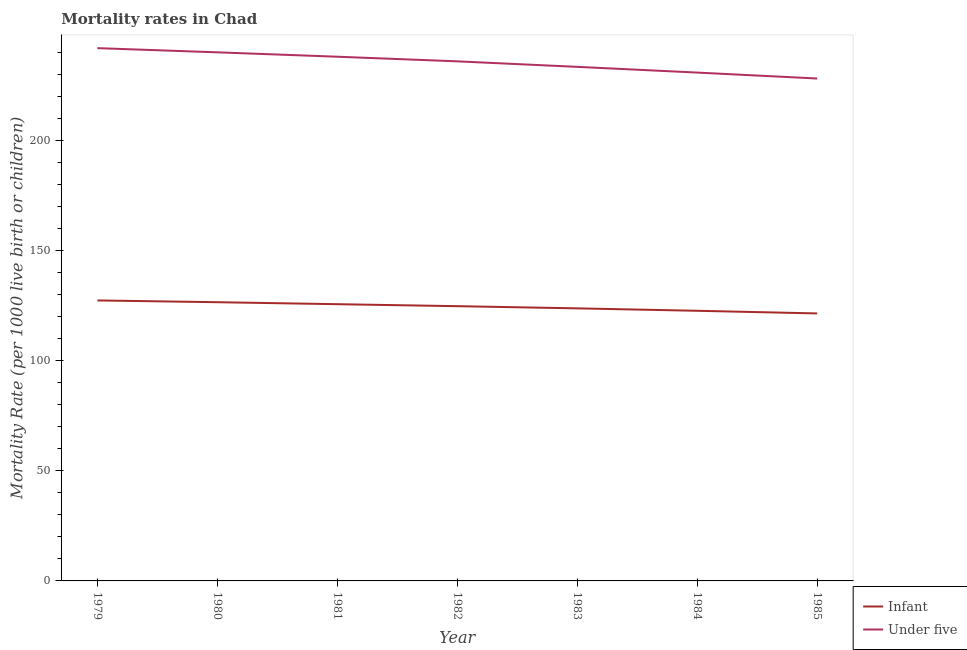How many different coloured lines are there?
Offer a very short reply. 2. Is the number of lines equal to the number of legend labels?
Keep it short and to the point. Yes. What is the under-5 mortality rate in 1984?
Offer a very short reply. 230.9. Across all years, what is the maximum infant mortality rate?
Give a very brief answer. 127.4. Across all years, what is the minimum under-5 mortality rate?
Provide a succinct answer. 228.2. In which year was the under-5 mortality rate maximum?
Ensure brevity in your answer.  1979. What is the total infant mortality rate in the graph?
Offer a terse response. 872.5. What is the difference between the infant mortality rate in 1979 and that in 1981?
Offer a terse response. 1.7. What is the difference between the under-5 mortality rate in 1985 and the infant mortality rate in 1980?
Keep it short and to the point. 101.6. What is the average infant mortality rate per year?
Give a very brief answer. 124.64. In the year 1979, what is the difference between the infant mortality rate and under-5 mortality rate?
Provide a succinct answer. -114.6. In how many years, is the infant mortality rate greater than 60?
Your answer should be very brief. 7. What is the ratio of the infant mortality rate in 1979 to that in 1984?
Your answer should be compact. 1.04. Is the infant mortality rate in 1984 less than that in 1985?
Your answer should be compact. No. Is the difference between the infant mortality rate in 1979 and 1982 greater than the difference between the under-5 mortality rate in 1979 and 1982?
Provide a short and direct response. No. What is the difference between the highest and the second highest under-5 mortality rate?
Ensure brevity in your answer.  1.9. What is the difference between the highest and the lowest under-5 mortality rate?
Offer a terse response. 13.8. In how many years, is the under-5 mortality rate greater than the average under-5 mortality rate taken over all years?
Keep it short and to the point. 4. Is the sum of the infant mortality rate in 1980 and 1984 greater than the maximum under-5 mortality rate across all years?
Give a very brief answer. Yes. Does the infant mortality rate monotonically increase over the years?
Offer a terse response. No. How many lines are there?
Keep it short and to the point. 2. Does the graph contain any zero values?
Your answer should be compact. No. Does the graph contain grids?
Provide a succinct answer. No. How many legend labels are there?
Keep it short and to the point. 2. What is the title of the graph?
Provide a succinct answer. Mortality rates in Chad. What is the label or title of the Y-axis?
Your answer should be very brief. Mortality Rate (per 1000 live birth or children). What is the Mortality Rate (per 1000 live birth or children) in Infant in 1979?
Give a very brief answer. 127.4. What is the Mortality Rate (per 1000 live birth or children) in Under five in 1979?
Provide a short and direct response. 242. What is the Mortality Rate (per 1000 live birth or children) of Infant in 1980?
Your answer should be compact. 126.6. What is the Mortality Rate (per 1000 live birth or children) of Under five in 1980?
Provide a short and direct response. 240.1. What is the Mortality Rate (per 1000 live birth or children) in Infant in 1981?
Offer a terse response. 125.7. What is the Mortality Rate (per 1000 live birth or children) of Under five in 1981?
Your answer should be compact. 238.1. What is the Mortality Rate (per 1000 live birth or children) of Infant in 1982?
Ensure brevity in your answer.  124.8. What is the Mortality Rate (per 1000 live birth or children) of Under five in 1982?
Provide a short and direct response. 236. What is the Mortality Rate (per 1000 live birth or children) of Infant in 1983?
Offer a terse response. 123.8. What is the Mortality Rate (per 1000 live birth or children) of Under five in 1983?
Provide a short and direct response. 233.5. What is the Mortality Rate (per 1000 live birth or children) in Infant in 1984?
Offer a very short reply. 122.7. What is the Mortality Rate (per 1000 live birth or children) of Under five in 1984?
Offer a terse response. 230.9. What is the Mortality Rate (per 1000 live birth or children) in Infant in 1985?
Give a very brief answer. 121.5. What is the Mortality Rate (per 1000 live birth or children) in Under five in 1985?
Ensure brevity in your answer.  228.2. Across all years, what is the maximum Mortality Rate (per 1000 live birth or children) of Infant?
Make the answer very short. 127.4. Across all years, what is the maximum Mortality Rate (per 1000 live birth or children) in Under five?
Make the answer very short. 242. Across all years, what is the minimum Mortality Rate (per 1000 live birth or children) in Infant?
Make the answer very short. 121.5. Across all years, what is the minimum Mortality Rate (per 1000 live birth or children) in Under five?
Offer a terse response. 228.2. What is the total Mortality Rate (per 1000 live birth or children) of Infant in the graph?
Make the answer very short. 872.5. What is the total Mortality Rate (per 1000 live birth or children) of Under five in the graph?
Offer a terse response. 1648.8. What is the difference between the Mortality Rate (per 1000 live birth or children) in Under five in 1979 and that in 1980?
Provide a succinct answer. 1.9. What is the difference between the Mortality Rate (per 1000 live birth or children) in Under five in 1979 and that in 1982?
Offer a terse response. 6. What is the difference between the Mortality Rate (per 1000 live birth or children) in Infant in 1979 and that in 1983?
Offer a very short reply. 3.6. What is the difference between the Mortality Rate (per 1000 live birth or children) of Under five in 1979 and that in 1984?
Your answer should be compact. 11.1. What is the difference between the Mortality Rate (per 1000 live birth or children) in Under five in 1979 and that in 1985?
Provide a succinct answer. 13.8. What is the difference between the Mortality Rate (per 1000 live birth or children) of Infant in 1980 and that in 1982?
Give a very brief answer. 1.8. What is the difference between the Mortality Rate (per 1000 live birth or children) of Infant in 1980 and that in 1983?
Offer a terse response. 2.8. What is the difference between the Mortality Rate (per 1000 live birth or children) in Under five in 1980 and that in 1984?
Your answer should be very brief. 9.2. What is the difference between the Mortality Rate (per 1000 live birth or children) of Infant in 1980 and that in 1985?
Ensure brevity in your answer.  5.1. What is the difference between the Mortality Rate (per 1000 live birth or children) of Under five in 1980 and that in 1985?
Offer a very short reply. 11.9. What is the difference between the Mortality Rate (per 1000 live birth or children) in Infant in 1981 and that in 1985?
Provide a succinct answer. 4.2. What is the difference between the Mortality Rate (per 1000 live birth or children) of Under five in 1981 and that in 1985?
Make the answer very short. 9.9. What is the difference between the Mortality Rate (per 1000 live birth or children) of Infant in 1979 and the Mortality Rate (per 1000 live birth or children) of Under five in 1980?
Keep it short and to the point. -112.7. What is the difference between the Mortality Rate (per 1000 live birth or children) of Infant in 1979 and the Mortality Rate (per 1000 live birth or children) of Under five in 1981?
Ensure brevity in your answer.  -110.7. What is the difference between the Mortality Rate (per 1000 live birth or children) of Infant in 1979 and the Mortality Rate (per 1000 live birth or children) of Under five in 1982?
Your answer should be very brief. -108.6. What is the difference between the Mortality Rate (per 1000 live birth or children) in Infant in 1979 and the Mortality Rate (per 1000 live birth or children) in Under five in 1983?
Ensure brevity in your answer.  -106.1. What is the difference between the Mortality Rate (per 1000 live birth or children) in Infant in 1979 and the Mortality Rate (per 1000 live birth or children) in Under five in 1984?
Your response must be concise. -103.5. What is the difference between the Mortality Rate (per 1000 live birth or children) in Infant in 1979 and the Mortality Rate (per 1000 live birth or children) in Under five in 1985?
Make the answer very short. -100.8. What is the difference between the Mortality Rate (per 1000 live birth or children) of Infant in 1980 and the Mortality Rate (per 1000 live birth or children) of Under five in 1981?
Offer a terse response. -111.5. What is the difference between the Mortality Rate (per 1000 live birth or children) of Infant in 1980 and the Mortality Rate (per 1000 live birth or children) of Under five in 1982?
Provide a short and direct response. -109.4. What is the difference between the Mortality Rate (per 1000 live birth or children) in Infant in 1980 and the Mortality Rate (per 1000 live birth or children) in Under five in 1983?
Offer a terse response. -106.9. What is the difference between the Mortality Rate (per 1000 live birth or children) in Infant in 1980 and the Mortality Rate (per 1000 live birth or children) in Under five in 1984?
Give a very brief answer. -104.3. What is the difference between the Mortality Rate (per 1000 live birth or children) in Infant in 1980 and the Mortality Rate (per 1000 live birth or children) in Under five in 1985?
Your answer should be compact. -101.6. What is the difference between the Mortality Rate (per 1000 live birth or children) of Infant in 1981 and the Mortality Rate (per 1000 live birth or children) of Under five in 1982?
Provide a short and direct response. -110.3. What is the difference between the Mortality Rate (per 1000 live birth or children) of Infant in 1981 and the Mortality Rate (per 1000 live birth or children) of Under five in 1983?
Your response must be concise. -107.8. What is the difference between the Mortality Rate (per 1000 live birth or children) of Infant in 1981 and the Mortality Rate (per 1000 live birth or children) of Under five in 1984?
Provide a short and direct response. -105.2. What is the difference between the Mortality Rate (per 1000 live birth or children) of Infant in 1981 and the Mortality Rate (per 1000 live birth or children) of Under five in 1985?
Give a very brief answer. -102.5. What is the difference between the Mortality Rate (per 1000 live birth or children) in Infant in 1982 and the Mortality Rate (per 1000 live birth or children) in Under five in 1983?
Give a very brief answer. -108.7. What is the difference between the Mortality Rate (per 1000 live birth or children) in Infant in 1982 and the Mortality Rate (per 1000 live birth or children) in Under five in 1984?
Your response must be concise. -106.1. What is the difference between the Mortality Rate (per 1000 live birth or children) in Infant in 1982 and the Mortality Rate (per 1000 live birth or children) in Under five in 1985?
Give a very brief answer. -103.4. What is the difference between the Mortality Rate (per 1000 live birth or children) of Infant in 1983 and the Mortality Rate (per 1000 live birth or children) of Under five in 1984?
Your response must be concise. -107.1. What is the difference between the Mortality Rate (per 1000 live birth or children) in Infant in 1983 and the Mortality Rate (per 1000 live birth or children) in Under five in 1985?
Your response must be concise. -104.4. What is the difference between the Mortality Rate (per 1000 live birth or children) in Infant in 1984 and the Mortality Rate (per 1000 live birth or children) in Under five in 1985?
Your answer should be very brief. -105.5. What is the average Mortality Rate (per 1000 live birth or children) in Infant per year?
Ensure brevity in your answer.  124.64. What is the average Mortality Rate (per 1000 live birth or children) of Under five per year?
Provide a succinct answer. 235.54. In the year 1979, what is the difference between the Mortality Rate (per 1000 live birth or children) of Infant and Mortality Rate (per 1000 live birth or children) of Under five?
Your answer should be compact. -114.6. In the year 1980, what is the difference between the Mortality Rate (per 1000 live birth or children) of Infant and Mortality Rate (per 1000 live birth or children) of Under five?
Your answer should be very brief. -113.5. In the year 1981, what is the difference between the Mortality Rate (per 1000 live birth or children) of Infant and Mortality Rate (per 1000 live birth or children) of Under five?
Offer a terse response. -112.4. In the year 1982, what is the difference between the Mortality Rate (per 1000 live birth or children) of Infant and Mortality Rate (per 1000 live birth or children) of Under five?
Your answer should be very brief. -111.2. In the year 1983, what is the difference between the Mortality Rate (per 1000 live birth or children) of Infant and Mortality Rate (per 1000 live birth or children) of Under five?
Ensure brevity in your answer.  -109.7. In the year 1984, what is the difference between the Mortality Rate (per 1000 live birth or children) of Infant and Mortality Rate (per 1000 live birth or children) of Under five?
Provide a succinct answer. -108.2. In the year 1985, what is the difference between the Mortality Rate (per 1000 live birth or children) in Infant and Mortality Rate (per 1000 live birth or children) in Under five?
Your answer should be very brief. -106.7. What is the ratio of the Mortality Rate (per 1000 live birth or children) in Infant in 1979 to that in 1980?
Your response must be concise. 1.01. What is the ratio of the Mortality Rate (per 1000 live birth or children) of Under five in 1979 to that in 1980?
Make the answer very short. 1.01. What is the ratio of the Mortality Rate (per 1000 live birth or children) in Infant in 1979 to that in 1981?
Provide a short and direct response. 1.01. What is the ratio of the Mortality Rate (per 1000 live birth or children) in Under five in 1979 to that in 1981?
Offer a terse response. 1.02. What is the ratio of the Mortality Rate (per 1000 live birth or children) in Infant in 1979 to that in 1982?
Your answer should be compact. 1.02. What is the ratio of the Mortality Rate (per 1000 live birth or children) of Under five in 1979 to that in 1982?
Provide a succinct answer. 1.03. What is the ratio of the Mortality Rate (per 1000 live birth or children) in Infant in 1979 to that in 1983?
Keep it short and to the point. 1.03. What is the ratio of the Mortality Rate (per 1000 live birth or children) of Under five in 1979 to that in 1983?
Provide a short and direct response. 1.04. What is the ratio of the Mortality Rate (per 1000 live birth or children) of Infant in 1979 to that in 1984?
Your response must be concise. 1.04. What is the ratio of the Mortality Rate (per 1000 live birth or children) in Under five in 1979 to that in 1984?
Your answer should be very brief. 1.05. What is the ratio of the Mortality Rate (per 1000 live birth or children) of Infant in 1979 to that in 1985?
Your response must be concise. 1.05. What is the ratio of the Mortality Rate (per 1000 live birth or children) in Under five in 1979 to that in 1985?
Make the answer very short. 1.06. What is the ratio of the Mortality Rate (per 1000 live birth or children) of Infant in 1980 to that in 1981?
Your answer should be compact. 1.01. What is the ratio of the Mortality Rate (per 1000 live birth or children) of Under five in 1980 to that in 1981?
Your answer should be compact. 1.01. What is the ratio of the Mortality Rate (per 1000 live birth or children) in Infant in 1980 to that in 1982?
Offer a terse response. 1.01. What is the ratio of the Mortality Rate (per 1000 live birth or children) in Under five in 1980 to that in 1982?
Offer a very short reply. 1.02. What is the ratio of the Mortality Rate (per 1000 live birth or children) in Infant in 1980 to that in 1983?
Offer a terse response. 1.02. What is the ratio of the Mortality Rate (per 1000 live birth or children) in Under five in 1980 to that in 1983?
Keep it short and to the point. 1.03. What is the ratio of the Mortality Rate (per 1000 live birth or children) in Infant in 1980 to that in 1984?
Your answer should be compact. 1.03. What is the ratio of the Mortality Rate (per 1000 live birth or children) in Under five in 1980 to that in 1984?
Provide a short and direct response. 1.04. What is the ratio of the Mortality Rate (per 1000 live birth or children) in Infant in 1980 to that in 1985?
Make the answer very short. 1.04. What is the ratio of the Mortality Rate (per 1000 live birth or children) in Under five in 1980 to that in 1985?
Your answer should be very brief. 1.05. What is the ratio of the Mortality Rate (per 1000 live birth or children) of Under five in 1981 to that in 1982?
Offer a terse response. 1.01. What is the ratio of the Mortality Rate (per 1000 live birth or children) of Infant in 1981 to that in 1983?
Provide a short and direct response. 1.02. What is the ratio of the Mortality Rate (per 1000 live birth or children) in Under five in 1981 to that in 1983?
Your answer should be very brief. 1.02. What is the ratio of the Mortality Rate (per 1000 live birth or children) of Infant in 1981 to that in 1984?
Provide a short and direct response. 1.02. What is the ratio of the Mortality Rate (per 1000 live birth or children) of Under five in 1981 to that in 1984?
Your answer should be compact. 1.03. What is the ratio of the Mortality Rate (per 1000 live birth or children) of Infant in 1981 to that in 1985?
Provide a succinct answer. 1.03. What is the ratio of the Mortality Rate (per 1000 live birth or children) of Under five in 1981 to that in 1985?
Provide a succinct answer. 1.04. What is the ratio of the Mortality Rate (per 1000 live birth or children) in Under five in 1982 to that in 1983?
Give a very brief answer. 1.01. What is the ratio of the Mortality Rate (per 1000 live birth or children) in Infant in 1982 to that in 1984?
Make the answer very short. 1.02. What is the ratio of the Mortality Rate (per 1000 live birth or children) of Under five in 1982 to that in 1984?
Offer a terse response. 1.02. What is the ratio of the Mortality Rate (per 1000 live birth or children) of Infant in 1982 to that in 1985?
Offer a terse response. 1.03. What is the ratio of the Mortality Rate (per 1000 live birth or children) in Under five in 1982 to that in 1985?
Your answer should be compact. 1.03. What is the ratio of the Mortality Rate (per 1000 live birth or children) of Under five in 1983 to that in 1984?
Ensure brevity in your answer.  1.01. What is the ratio of the Mortality Rate (per 1000 live birth or children) in Infant in 1983 to that in 1985?
Ensure brevity in your answer.  1.02. What is the ratio of the Mortality Rate (per 1000 live birth or children) of Under five in 1983 to that in 1985?
Your response must be concise. 1.02. What is the ratio of the Mortality Rate (per 1000 live birth or children) in Infant in 1984 to that in 1985?
Keep it short and to the point. 1.01. What is the ratio of the Mortality Rate (per 1000 live birth or children) of Under five in 1984 to that in 1985?
Offer a very short reply. 1.01. What is the difference between the highest and the second highest Mortality Rate (per 1000 live birth or children) of Infant?
Ensure brevity in your answer.  0.8. What is the difference between the highest and the second highest Mortality Rate (per 1000 live birth or children) in Under five?
Make the answer very short. 1.9. What is the difference between the highest and the lowest Mortality Rate (per 1000 live birth or children) of Under five?
Keep it short and to the point. 13.8. 